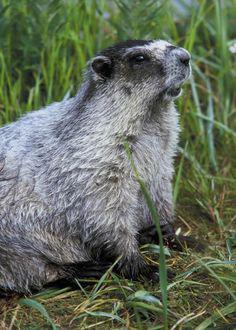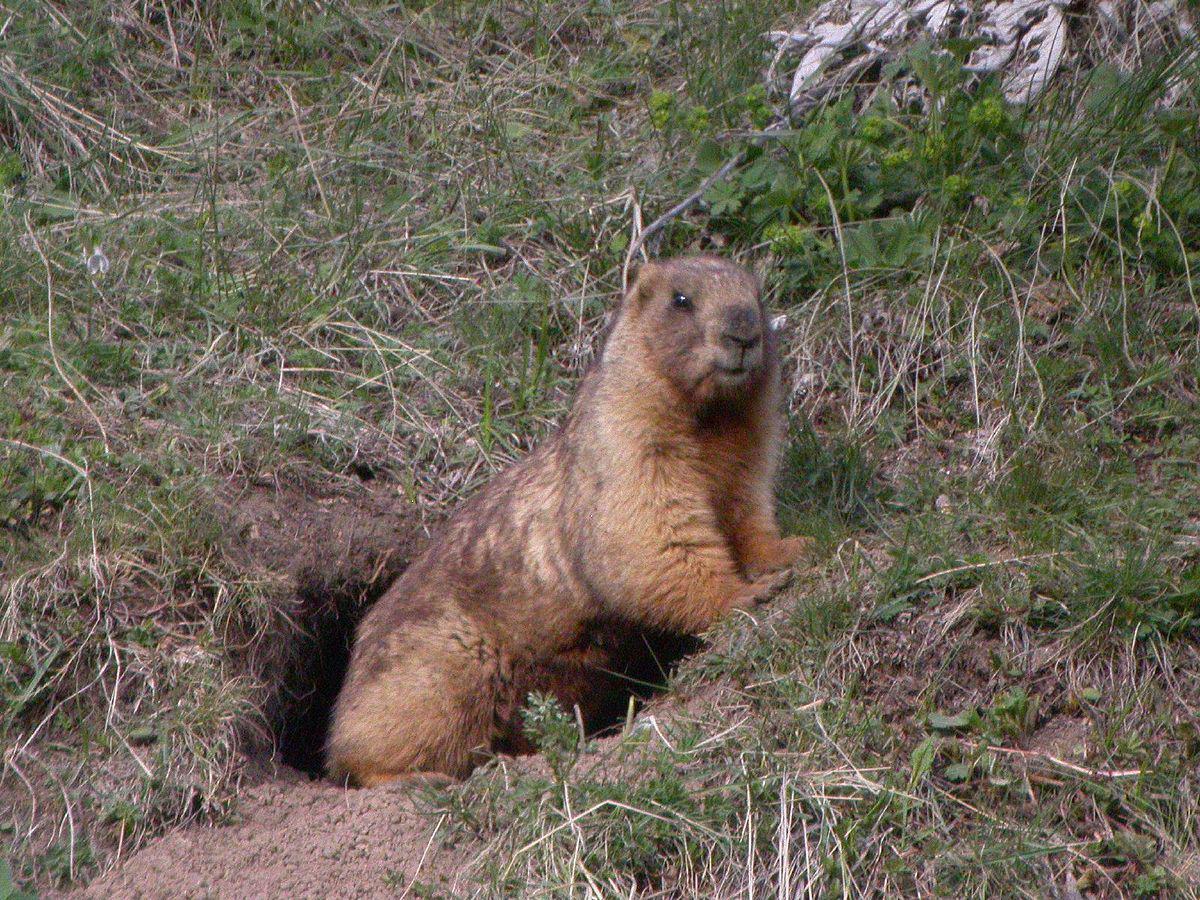The first image is the image on the left, the second image is the image on the right. For the images displayed, is the sentence "The left and right image contains the same number of groundhogs with at least one sitting on their butt." factually correct? Answer yes or no. No. 